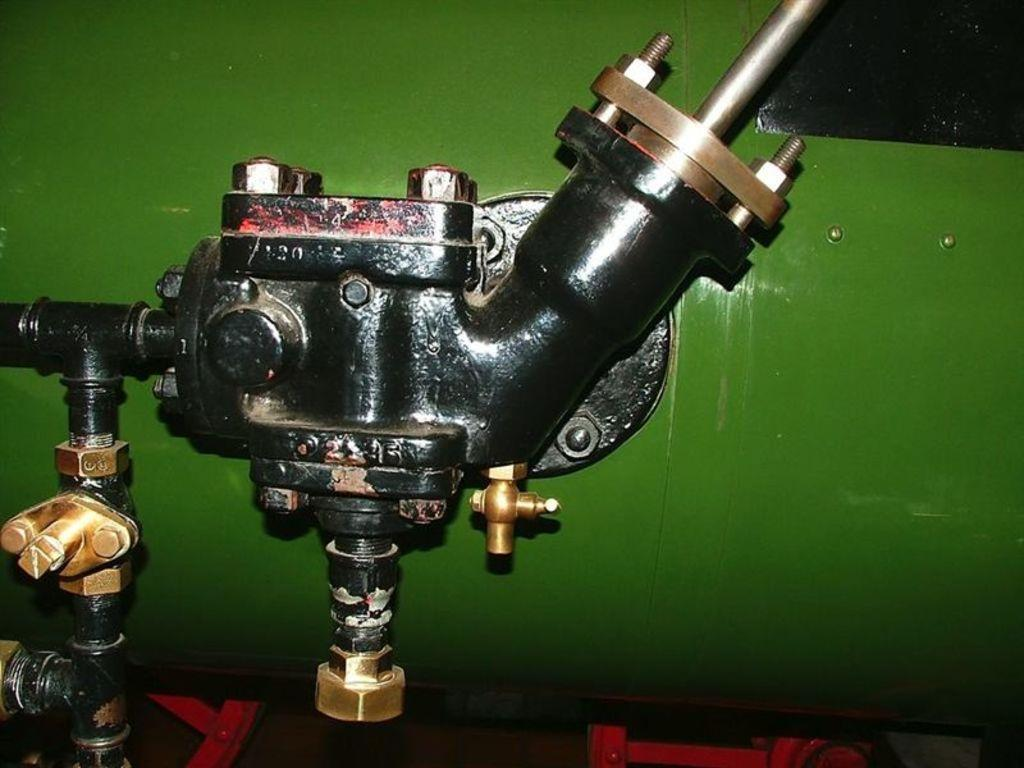What is the main subject of the image? The main subject of the image is a mechanical part of a device. Can you describe the mechanical part in more detail? Unfortunately, the provided facts do not offer more detail about the mechanical part. However, it is clear that it is a significant component of a device. What type of cheese is being grated by the mechanical part in the image? There is no cheese or grating activity present in the image. The image only features a mechanical part of a device. 